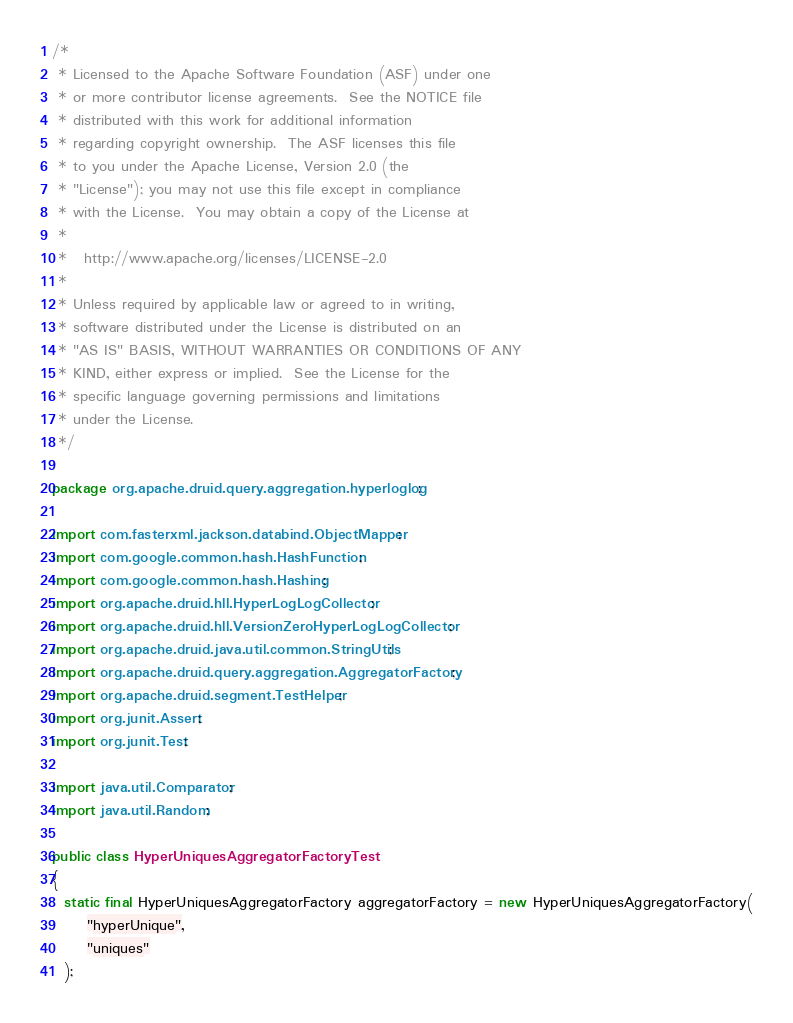Convert code to text. <code><loc_0><loc_0><loc_500><loc_500><_Java_>/*
 * Licensed to the Apache Software Foundation (ASF) under one
 * or more contributor license agreements.  See the NOTICE file
 * distributed with this work for additional information
 * regarding copyright ownership.  The ASF licenses this file
 * to you under the Apache License, Version 2.0 (the
 * "License"); you may not use this file except in compliance
 * with the License.  You may obtain a copy of the License at
 *
 *   http://www.apache.org/licenses/LICENSE-2.0
 *
 * Unless required by applicable law or agreed to in writing,
 * software distributed under the License is distributed on an
 * "AS IS" BASIS, WITHOUT WARRANTIES OR CONDITIONS OF ANY
 * KIND, either express or implied.  See the License for the
 * specific language governing permissions and limitations
 * under the License.
 */

package org.apache.druid.query.aggregation.hyperloglog;

import com.fasterxml.jackson.databind.ObjectMapper;
import com.google.common.hash.HashFunction;
import com.google.common.hash.Hashing;
import org.apache.druid.hll.HyperLogLogCollector;
import org.apache.druid.hll.VersionZeroHyperLogLogCollector;
import org.apache.druid.java.util.common.StringUtils;
import org.apache.druid.query.aggregation.AggregatorFactory;
import org.apache.druid.segment.TestHelper;
import org.junit.Assert;
import org.junit.Test;

import java.util.Comparator;
import java.util.Random;

public class HyperUniquesAggregatorFactoryTest
{
  static final HyperUniquesAggregatorFactory aggregatorFactory = new HyperUniquesAggregatorFactory(
      "hyperUnique",
      "uniques"
  );</code> 